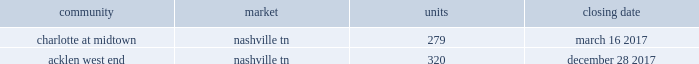2022 secondary market same store communities are generally communities in markets with populations of more than 1 million but less than 1% ( 1 % ) of the total public multifamily reit units or markets with populations of less than 1 million that we have owned and have been stabilized for at least a full 12 months .
2022 non-same store communities and other includes recent acquisitions , communities in development or lease-up , communities that have been identified for disposition , and communities that have undergone a significant casualty loss .
Also included in non-same store communities are non-multifamily activities .
On the first day of each calendar year , we determine the composition of our same store operating segments for that year as well as adjust the previous year , which allows us to evaluate full period-over-period operating comparisons .
An apartment community in development or lease-up is added to the same store portfolio on the first day of the calendar year after it has been owned and stabilized for at least a full 12 months .
Communities are considered stabilized after achieving 90% ( 90 % ) occupancy for 90 days .
Communities that have been identified for disposition are excluded from the same store portfolio .
All properties acquired from post properties in the merger remained in the non-same store and other operating segment during 2017 , as the properties were recent acquisitions and had not been owned and stabilized for at least 12 months as of january 1 , 2017 .
For additional information regarding our operating segments , see note 14 to the consolidated financial statements included elsewhere in this annual report on form 10-k .
Acquisitions one of our growth strategies is to acquire apartment communities that are located in various large or secondary markets primarily throughout the southeast and southwest regions of the united states .
Acquisitions , along with dispositions , help us achieve and maintain our desired product mix , geographic diversification and asset allocation .
Portfolio growth allows for maximizing the efficiency of the existing management and overhead structure .
We have extensive experience in the acquisition of multifamily communities .
We will continue to evaluate opportunities that arise , and we will utilize this strategy to increase our number of apartment communities in strong and growing markets .
We acquired the following apartment communities during the year ended december 31 , 2017: .
Dispositions we sell apartment communities and other assets that no longer meet our long-term strategy or when market conditions are favorable , and we redeploy the proceeds from those sales to acquire , develop and redevelop additional apartment communities and rebalance our portfolio across or within geographic regions .
Dispositions also allow us to realize a portion of the value created through our investments and provide additional liquidity .
We are then able to redeploy the net proceeds from our dispositions in lieu of raising additional capital .
In deciding to sell an apartment community , we consider current market conditions and generally solicit competing bids from unrelated parties for these individual assets , considering the sales price and other key terms of each proposal .
We also consider portfolio dispositions when such a structure is useful to maximize proceeds and efficiency of execution .
During the year ended december 31 , 2017 , we disposed of five multifamily properties totaling 1760 units and four land parcels totaling approximately 23 acres .
Development as another part of our growth strategy , we invest in a limited number of development projects .
Development activities may be conducted through wholly-owned affiliated companies or through joint ventures with unaffiliated parties .
Fixed price construction contracts are signed with unrelated parties to minimize construction risk .
We typically manage the leasing portion of the project as units become available for lease .
We may also engage in limited expansion development opportunities on existing communities in which we typically serve as the developer .
While we seek opportunistic new development investments offering attractive long-term investment returns , we intend to maintain a total development commitment that we consider modest in relation to our total balance sheet and investment portfolio .
During the year ended december 31 , 2017 , we incurred $ 170.1 million in development costs and completed 7 development projects. .
What is the difference between the number of units in charlotte at midtown and acklen west end? 
Rationale: it is the difference between the number of units at each location .
Computations: (320 - 279)
Answer: 41.0. 